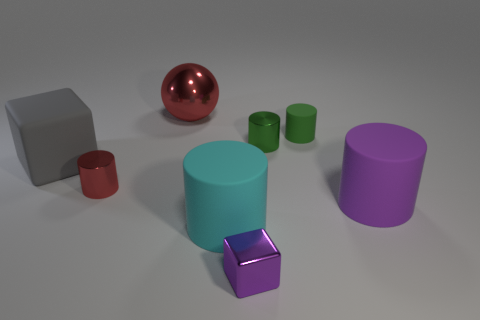Is the cube that is to the right of the gray thing made of the same material as the big red thing?
Your answer should be very brief. Yes. What color is the tiny object that is the same shape as the large gray rubber object?
Your response must be concise. Purple. What number of other things are the same color as the large cube?
Your response must be concise. 0. There is a big matte object that is to the left of the cyan matte object; is its shape the same as the red object that is left of the red metal ball?
Keep it short and to the point. No. How many cubes are small green shiny things or small brown metallic objects?
Provide a short and direct response. 0. Are there fewer cylinders on the left side of the red cylinder than spheres?
Your answer should be compact. Yes. How many other objects are there of the same material as the purple cylinder?
Offer a terse response. 3. Do the green shiny thing and the cyan rubber object have the same size?
Offer a very short reply. No. How many objects are large matte things in front of the purple rubber cylinder or large gray things?
Keep it short and to the point. 2. What material is the big cylinder that is to the left of the cube in front of the cyan cylinder?
Give a very brief answer. Rubber. 